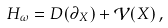<formula> <loc_0><loc_0><loc_500><loc_500>H _ { \omega } = D ( \partial _ { X } ) + \mathcal { V } ( X ) \, ,</formula> 